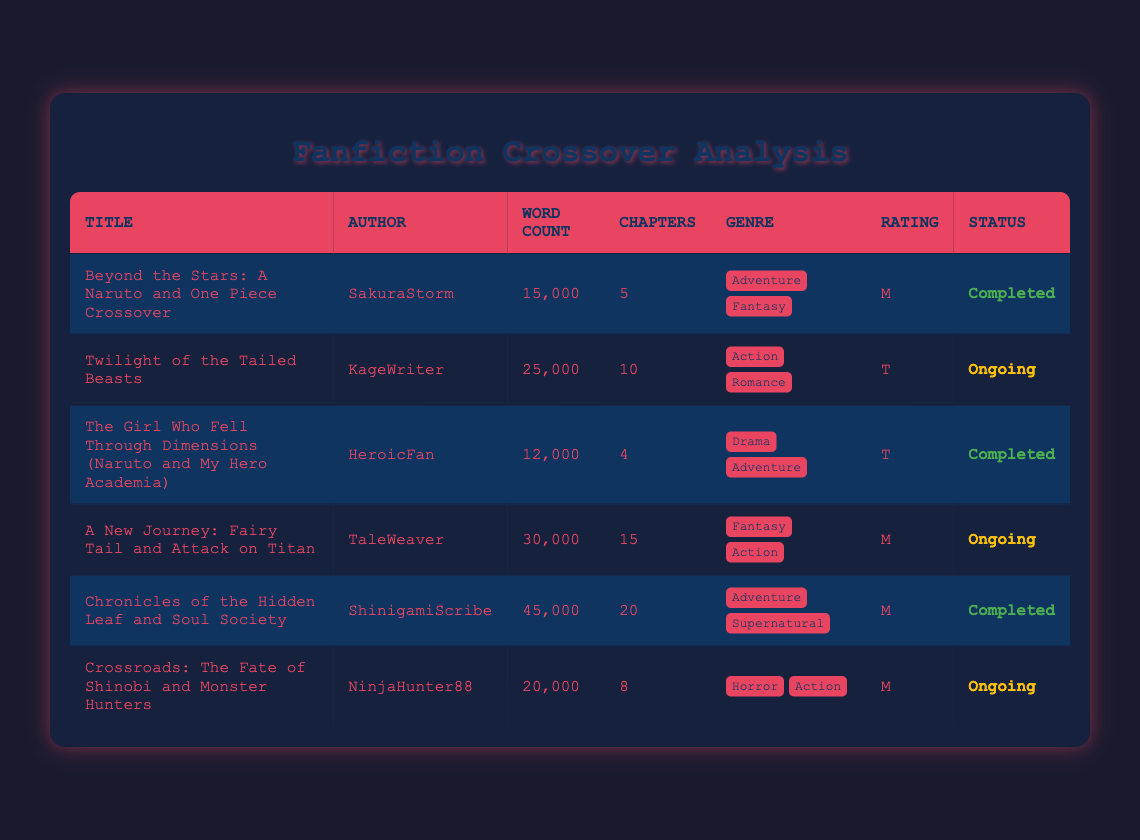What is the title of the fanfiction with the highest word count? By examining the "word count" column, we find that "Chronicles of the Hidden Leaf and Soul Society" has the highest value of 45000 words.
Answer: Chronicles of the Hidden Leaf and Soul Society How many fanfictions have a status of "Ongoing"? Looking at the "status" column, we count the entries marked as "Ongoing", which include "Twilight of the Tailed Beasts", "A New Journey: Fairy Tail and Attack on Titan", and "Crossroads: The Fate of Shinobi and Monster Hunters", totaling three.
Answer: 3 What is the average word count of the completed fanfictions? The completed fanfictions are "Beyond the Stars: A Naruto and One Piece Crossover", "The Girl Who Fell Through Dimensions", and "Chronicles of the Hidden Leaf and Soul Society". Their word counts are 15000, 12000, and 45000 respectively. The total is 15000 + 12000 + 45000 = 72000. There are 3 completed fanfictions, so the average is 72000 / 3 = 24000.
Answer: 24000 Is there any fanfiction that combines action and horror genres? By reviewing the "genre" columns, we find that "Crossroads: The Fate of Shinobi and Monster Hunters" includes both "Horror" and "Action", therefore, this fanfiction meets the criteria.
Answer: Yes What is the total number of chapters across all fanfictions? We will sum the "chapters" column: 5 + 10 + 4 + 15 + 20 + 8 = 72. Thus, the total number of chapters across all the fanfictions is 72.
Answer: 72 Which fanfiction has the least number of chapters, and what is that number? Inspecting the "chapters" column, we see that "The Girl Who Fell Through Dimensions" has the smallest value of 4 chapters.
Answer: 4 